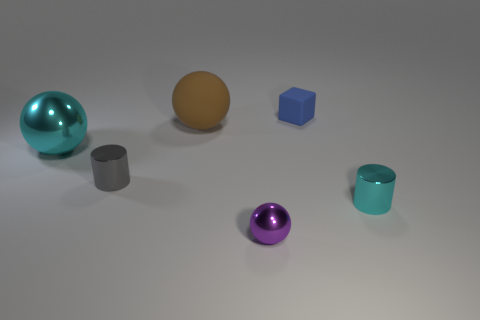Add 2 gray blocks. How many objects exist? 8 Subtract all blocks. How many objects are left? 5 Add 3 small shiny cylinders. How many small shiny cylinders exist? 5 Subtract 0 blue cylinders. How many objects are left? 6 Subtract all tiny red matte blocks. Subtract all shiny spheres. How many objects are left? 4 Add 6 tiny blue rubber cubes. How many tiny blue rubber cubes are left? 7 